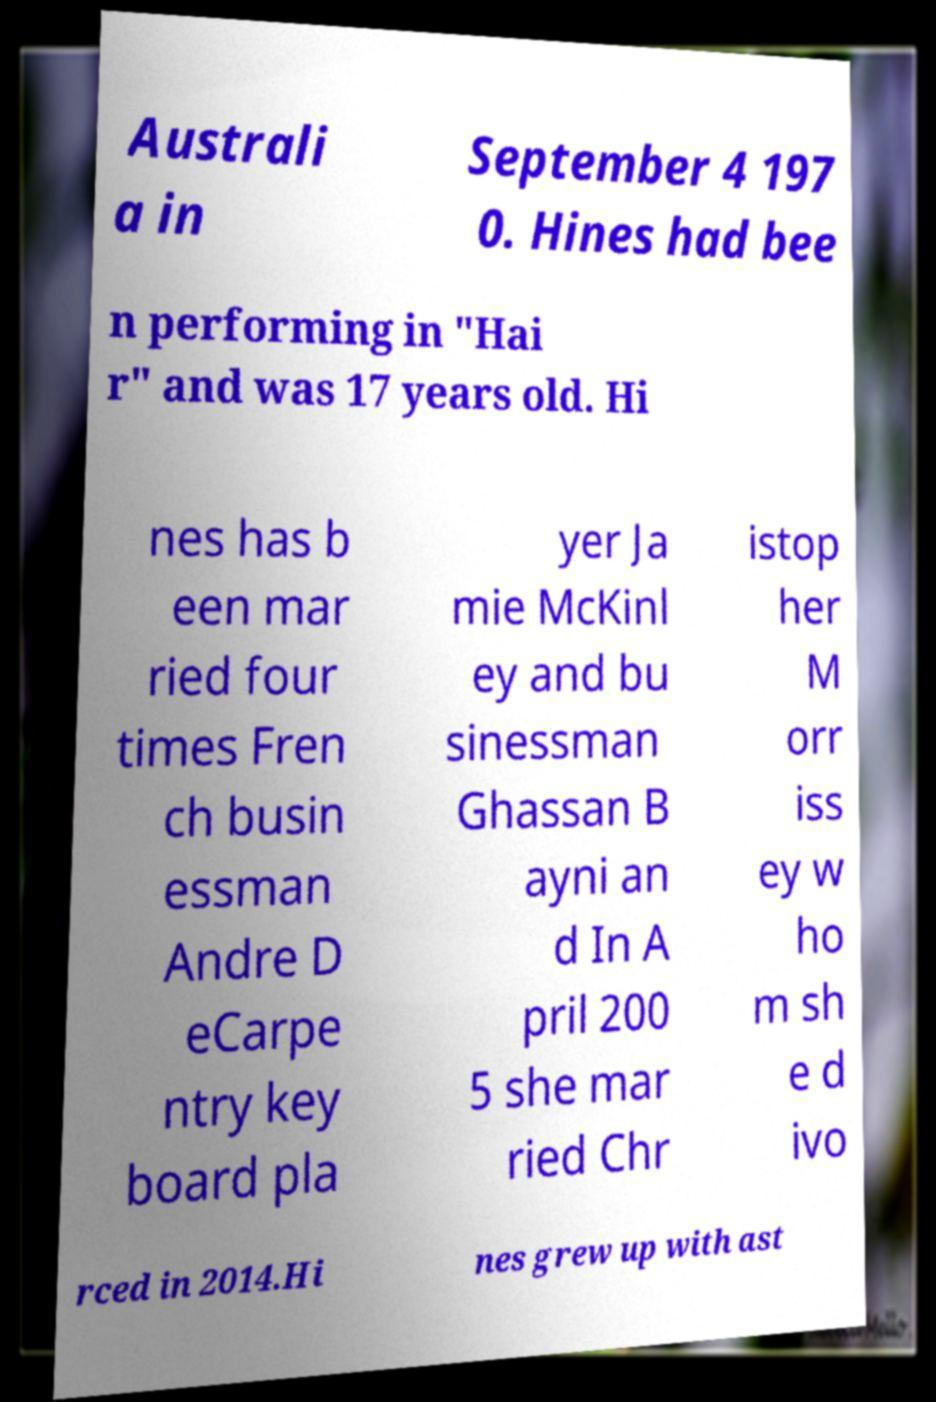What messages or text are displayed in this image? I need them in a readable, typed format. Australi a in September 4 197 0. Hines had bee n performing in "Hai r" and was 17 years old. Hi nes has b een mar ried four times Fren ch busin essman Andre D eCarpe ntry key board pla yer Ja mie McKinl ey and bu sinessman Ghassan B ayni an d In A pril 200 5 she mar ried Chr istop her M orr iss ey w ho m sh e d ivo rced in 2014.Hi nes grew up with ast 